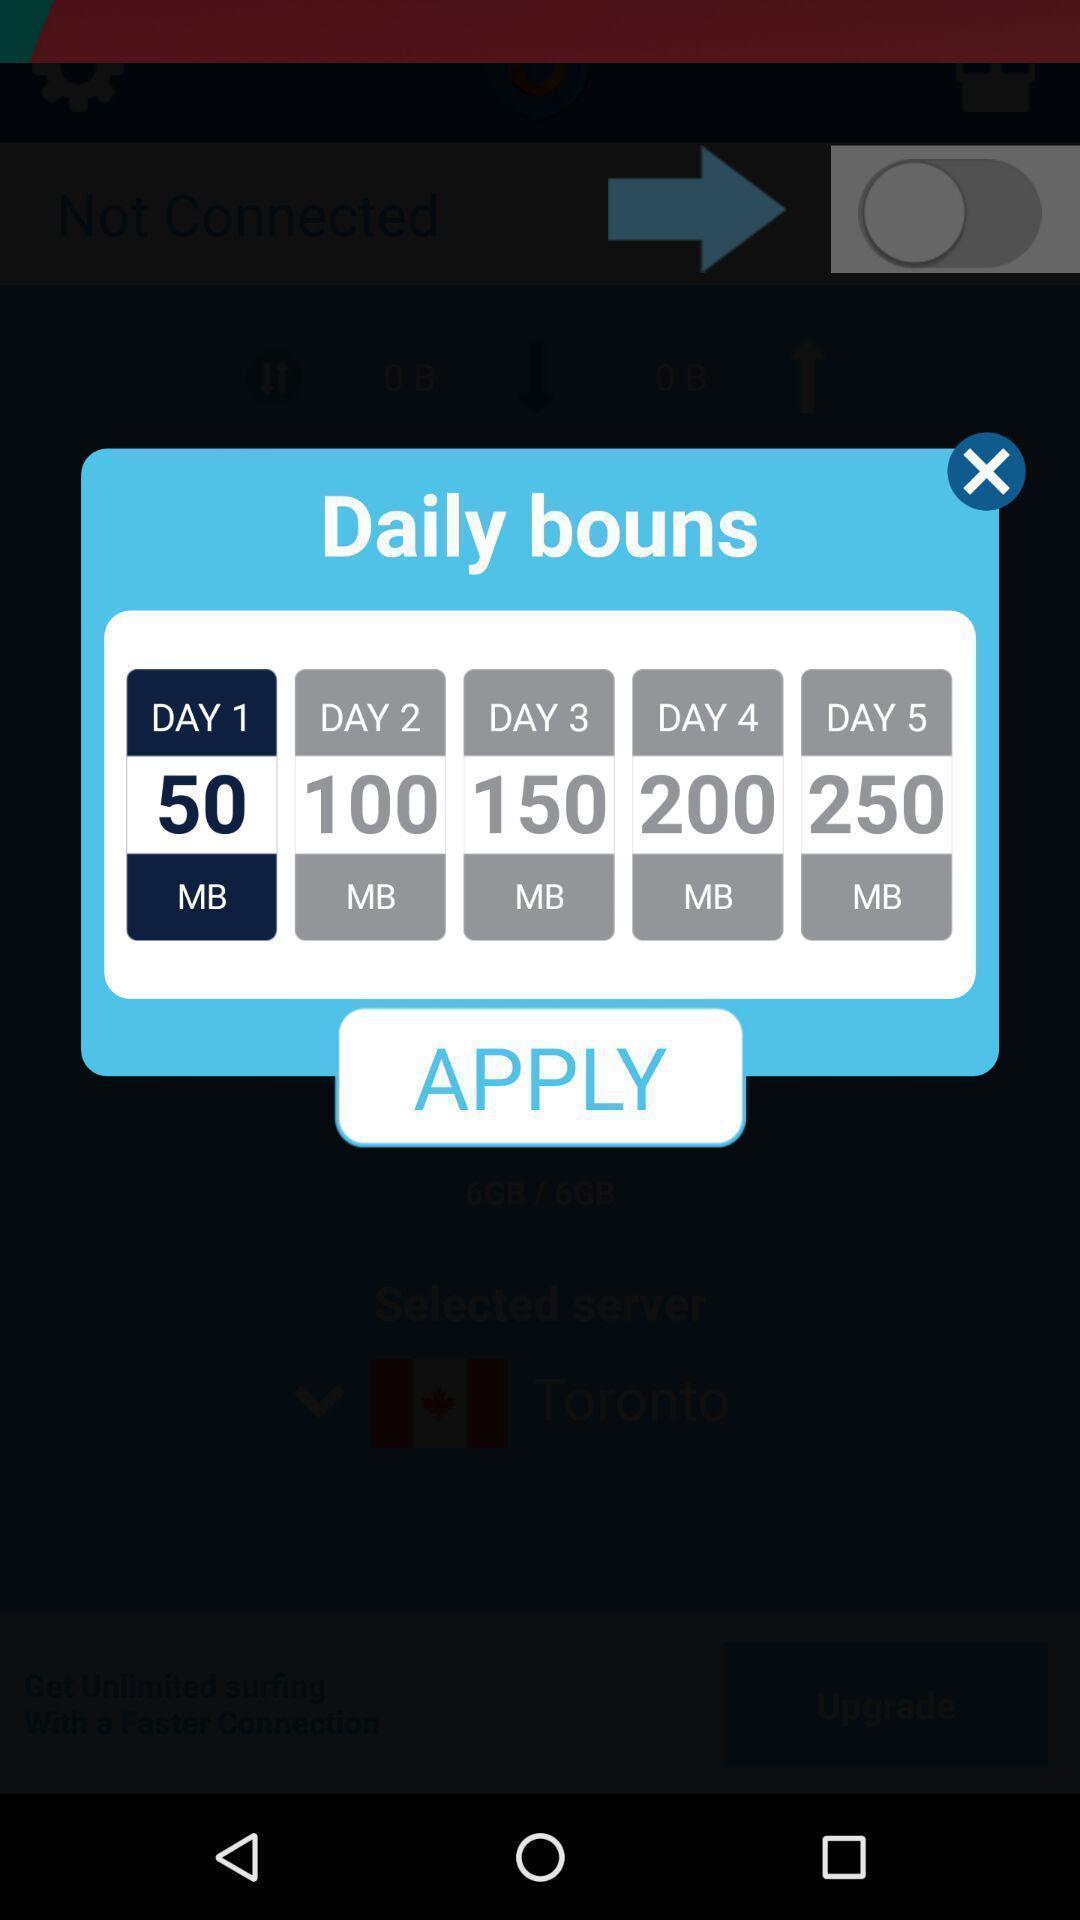Please provide a description for this image. Pop up to claim options in financial app. 